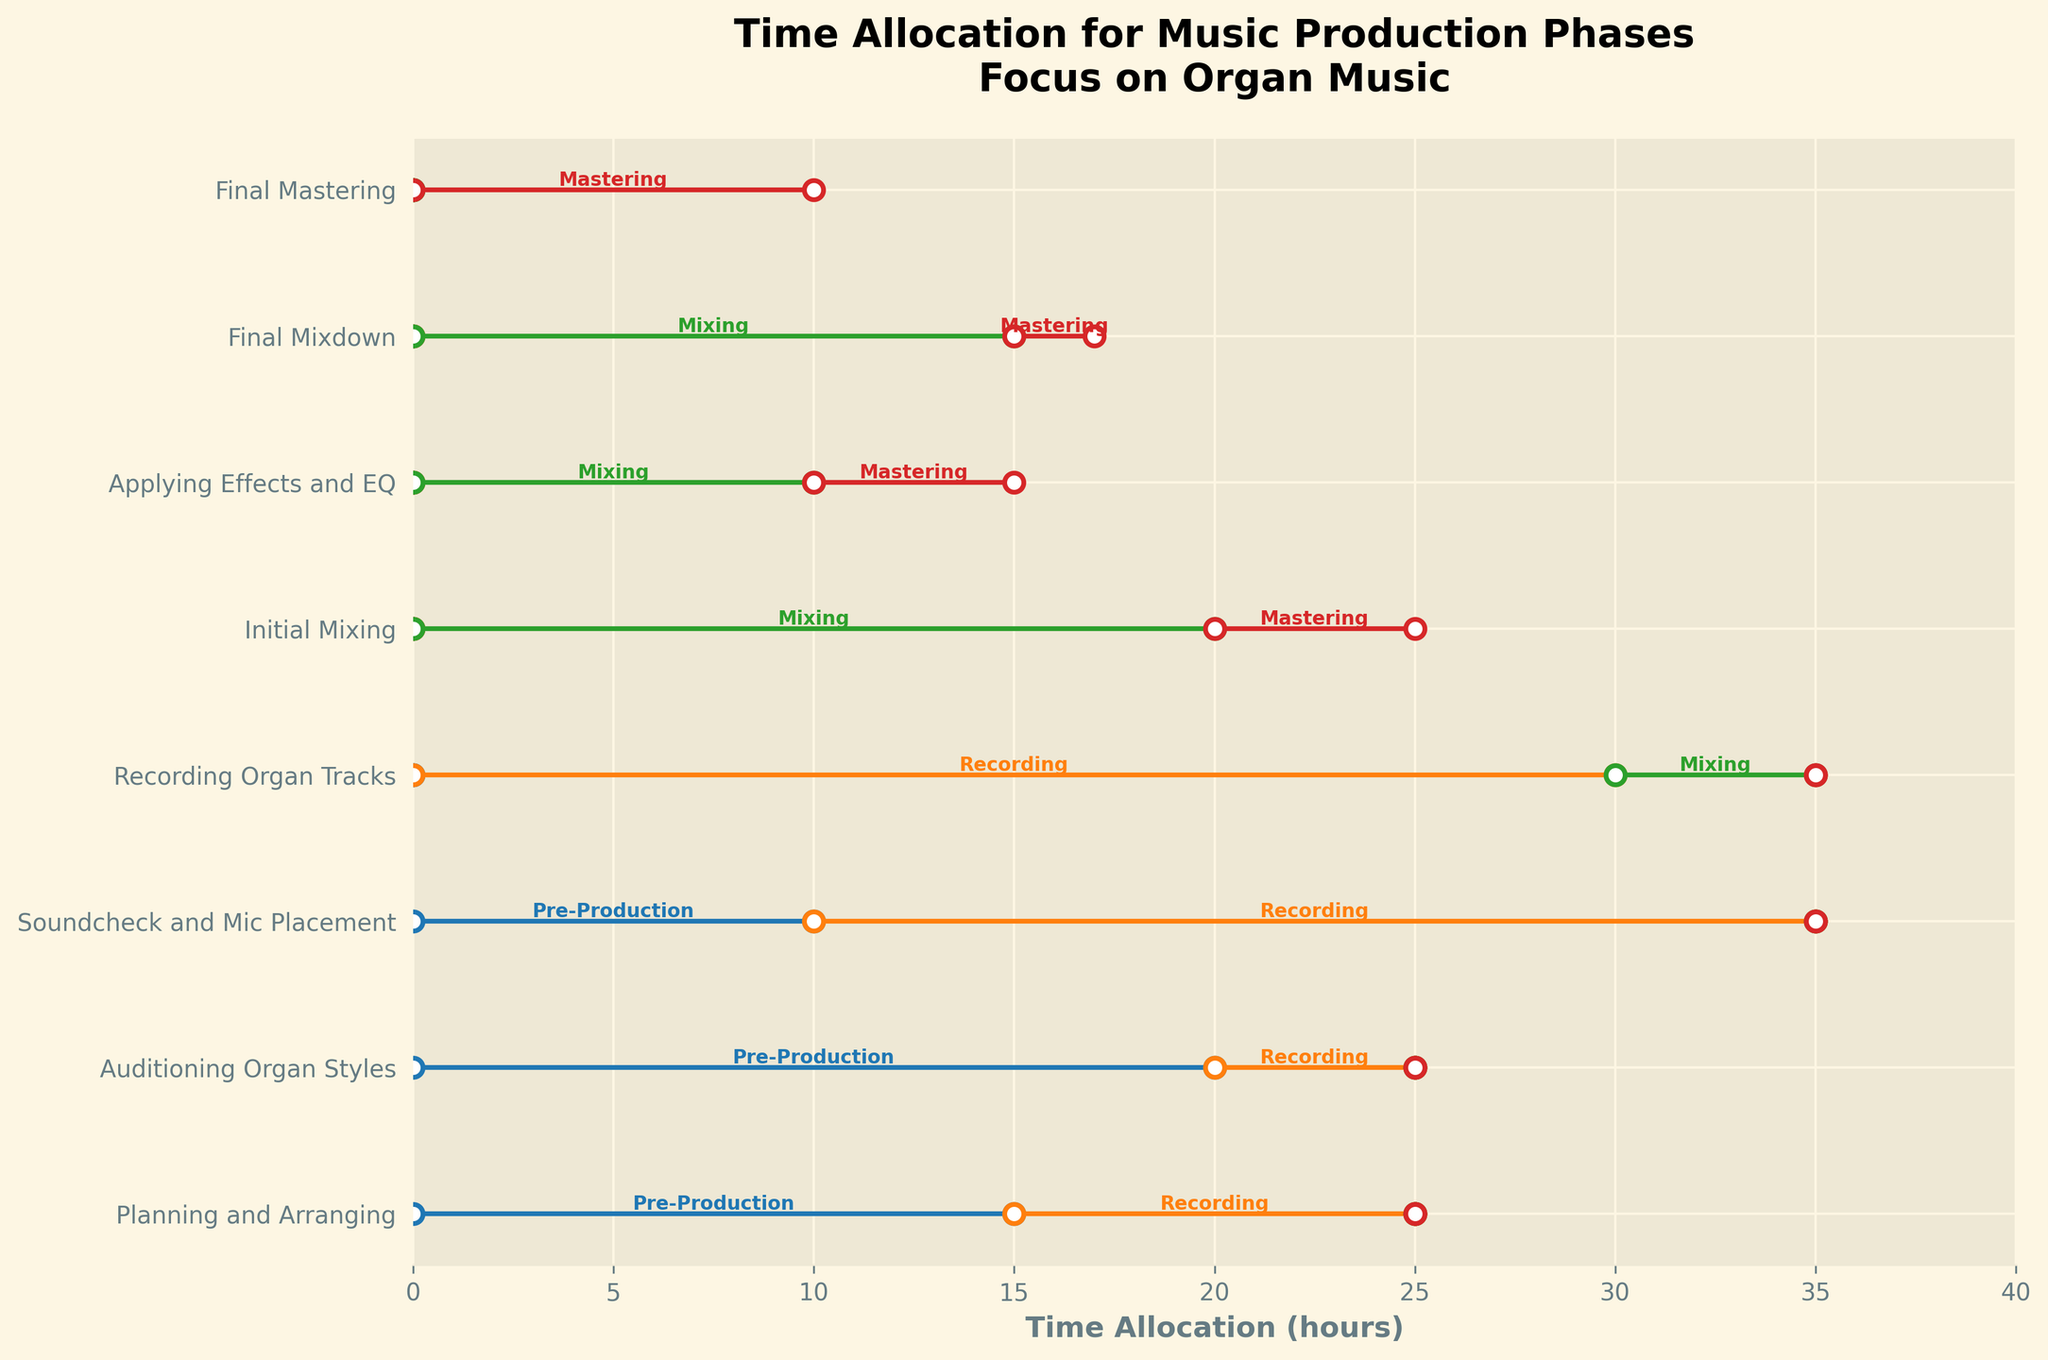What's the title of the plot? The title is located at the top of the plot where it gives an overview of what the plot represents.
Answer: Time Allocation for Music Production Phases: Focus on Organ Music How much time did Anna Smith allocate to Auditioning Organ Styles? Locate the "Auditioning Organ Styles" section and note the time allocation for each phase.
Answer: 20 hours for Pre-Production and 5 hours for Recording Which phase did John Doe spend the most time on? Look at "John Doe" row and see which phase has the longest segment.
Answer: Recording (25 hours) How does Sarah Lee's time spent on Recording compare to Chris Brown's time spent on Mixing? Compare the lengths of the Recording segment for "Sarah Lee" and the Mixing segment for "Chris Brown".
Answer: Sarah Lee spent 30 hours on Recording, while Chris Brown spent 20 hours on Mixing In which phase did Emily White allocate time, apart from Mixing? Identify the phases Emily White contributed to by examining segments in her row.
Answer: Mastering (2 hours) What is the total time Mike Jones spent on his project? Sum up all the time allocations for Mike Jones.
Answer: 25 hours (15 hours for Pre-Production and 10 hours for Recording) Who allocated 10 hours to Soundcheck and Mic Placement? Check the row for "Soundcheck and Mic Placement" and locate the time allocated.
Answer: John Doe How much time did David Clark spend on Mixing phases? Identify both Mixing-related stages and sum the time allocated.
Answer: 15 hours (10 hours for Applying Effects and EQ, and 5 hours for Mastering) Which phase has the highest cumulative time across all projects? Sum the time allocation for each phase across all rows and identify the highest sum.
Answer: Recording Was there any project where no time was allocated to Pre-Production? Check each project's Pre-Production segment to see if it shows 0 hours.
Answer: Sarah Lee, Chris Brown, David Clark, Emily White, and Oliver Green spent 0 hours on Pre-Production 